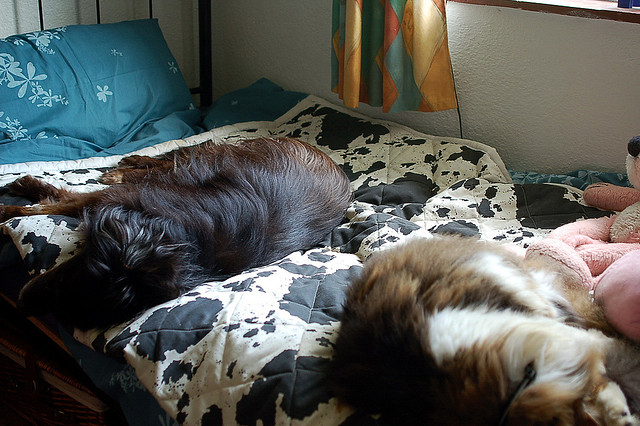Can you describe the colors and patterns in this room? Certainly! The room features a multi-colored theme, with the bed adorned by a black and white cow-patterned duvet. There's a striking contrast with the turquoise blue pillow that adds a splash of vibrant color to the room. The warmth is reflected through the orange curtains in the background, creating a cozy and eclectic aesthetic. 